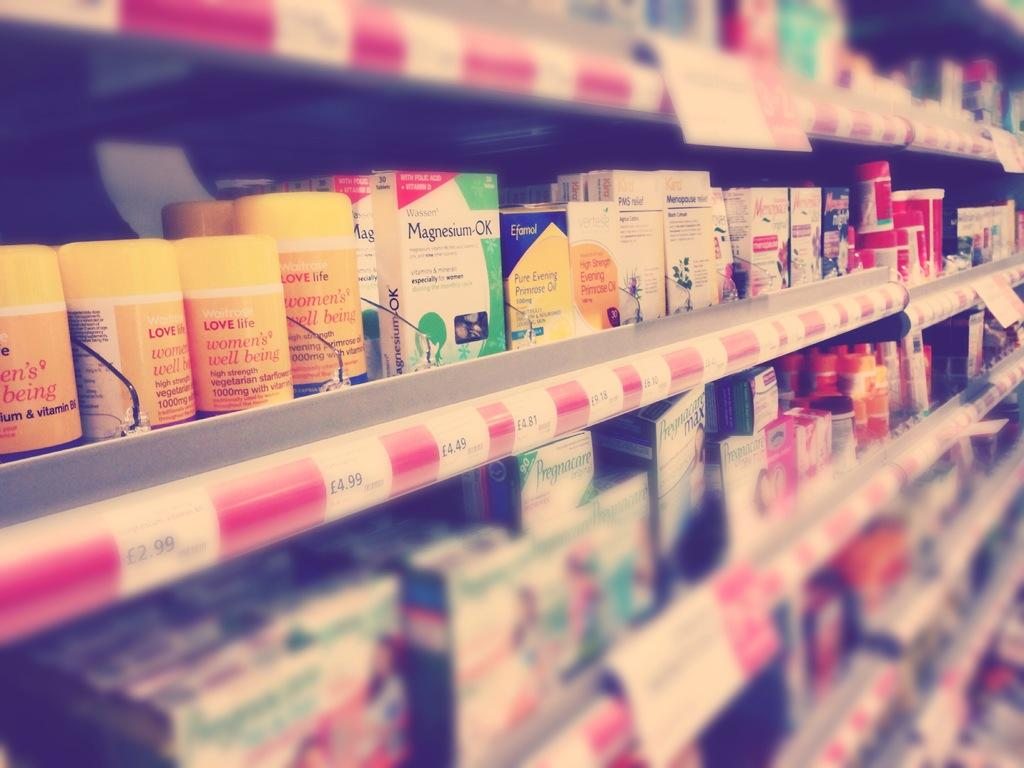<image>
Create a compact narrative representing the image presented. The shelves with pharmacy products including items called Magnesium-OK. 